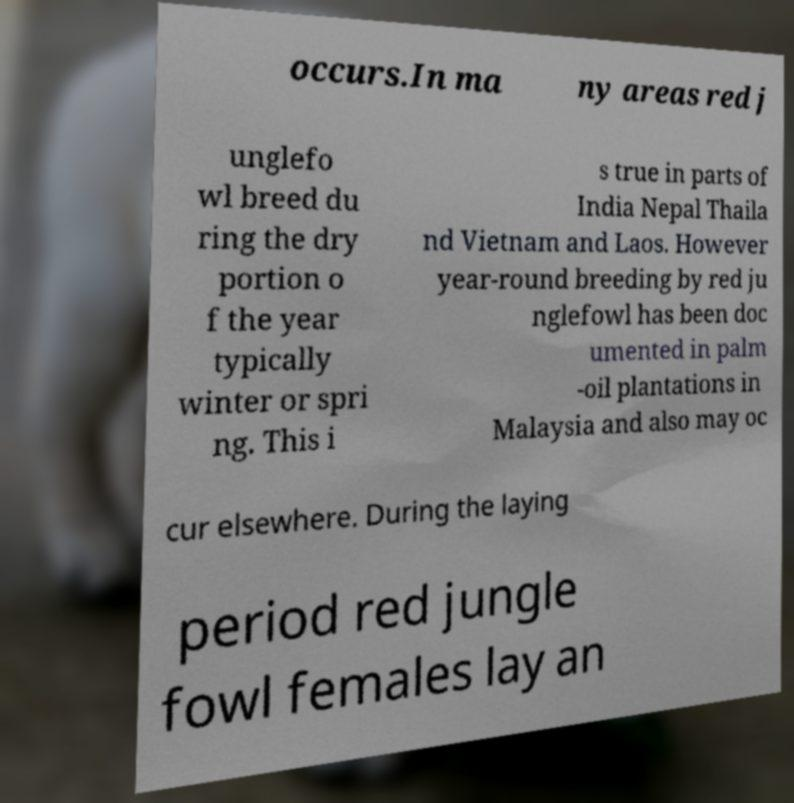What messages or text are displayed in this image? I need them in a readable, typed format. occurs.In ma ny areas red j unglefo wl breed du ring the dry portion o f the year typically winter or spri ng. This i s true in parts of India Nepal Thaila nd Vietnam and Laos. However year-round breeding by red ju nglefowl has been doc umented in palm -oil plantations in Malaysia and also may oc cur elsewhere. During the laying period red jungle fowl females lay an 